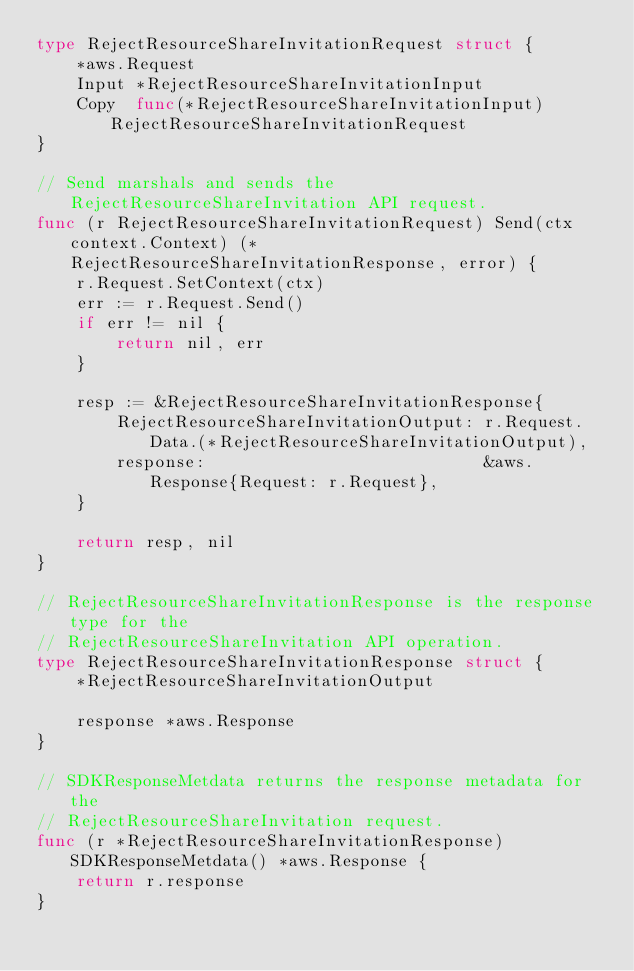Convert code to text. <code><loc_0><loc_0><loc_500><loc_500><_Go_>type RejectResourceShareInvitationRequest struct {
	*aws.Request
	Input *RejectResourceShareInvitationInput
	Copy  func(*RejectResourceShareInvitationInput) RejectResourceShareInvitationRequest
}

// Send marshals and sends the RejectResourceShareInvitation API request.
func (r RejectResourceShareInvitationRequest) Send(ctx context.Context) (*RejectResourceShareInvitationResponse, error) {
	r.Request.SetContext(ctx)
	err := r.Request.Send()
	if err != nil {
		return nil, err
	}

	resp := &RejectResourceShareInvitationResponse{
		RejectResourceShareInvitationOutput: r.Request.Data.(*RejectResourceShareInvitationOutput),
		response:                            &aws.Response{Request: r.Request},
	}

	return resp, nil
}

// RejectResourceShareInvitationResponse is the response type for the
// RejectResourceShareInvitation API operation.
type RejectResourceShareInvitationResponse struct {
	*RejectResourceShareInvitationOutput

	response *aws.Response
}

// SDKResponseMetdata returns the response metadata for the
// RejectResourceShareInvitation request.
func (r *RejectResourceShareInvitationResponse) SDKResponseMetdata() *aws.Response {
	return r.response
}
</code> 